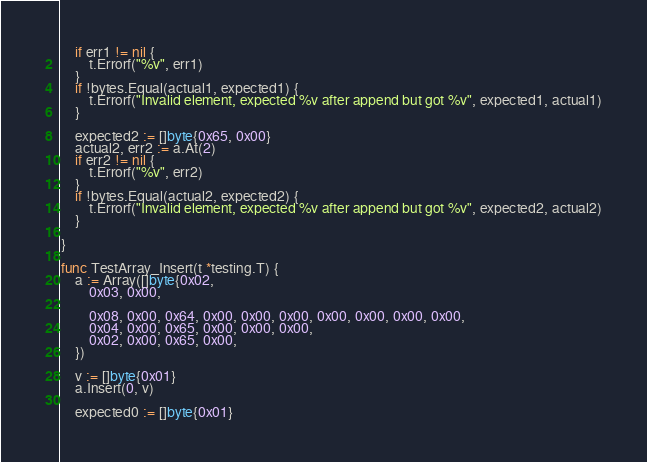<code> <loc_0><loc_0><loc_500><loc_500><_Go_>	if err1 != nil {
		t.Errorf("%v", err1)
	}
	if !bytes.Equal(actual1, expected1) {
		t.Errorf("Invalid element, expected %v after append but got %v", expected1, actual1)
	}

	expected2 := []byte{0x65, 0x00}
	actual2, err2 := a.At(2)
	if err2 != nil {
		t.Errorf("%v", err2)
	}
	if !bytes.Equal(actual2, expected2) {
		t.Errorf("Invalid element, expected %v after append but got %v", expected2, actual2)
	}

}

func TestArray_Insert(t *testing.T) {
	a := Array([]byte{0x02,
		0x03, 0x00,

		0x08, 0x00, 0x64, 0x00, 0x00, 0x00, 0x00, 0x00, 0x00, 0x00,
		0x04, 0x00, 0x65, 0x00, 0x00, 0x00,
		0x02, 0x00, 0x65, 0x00,
	})

	v := []byte{0x01}
	a.Insert(0, v)

	expected0 := []byte{0x01}</code> 